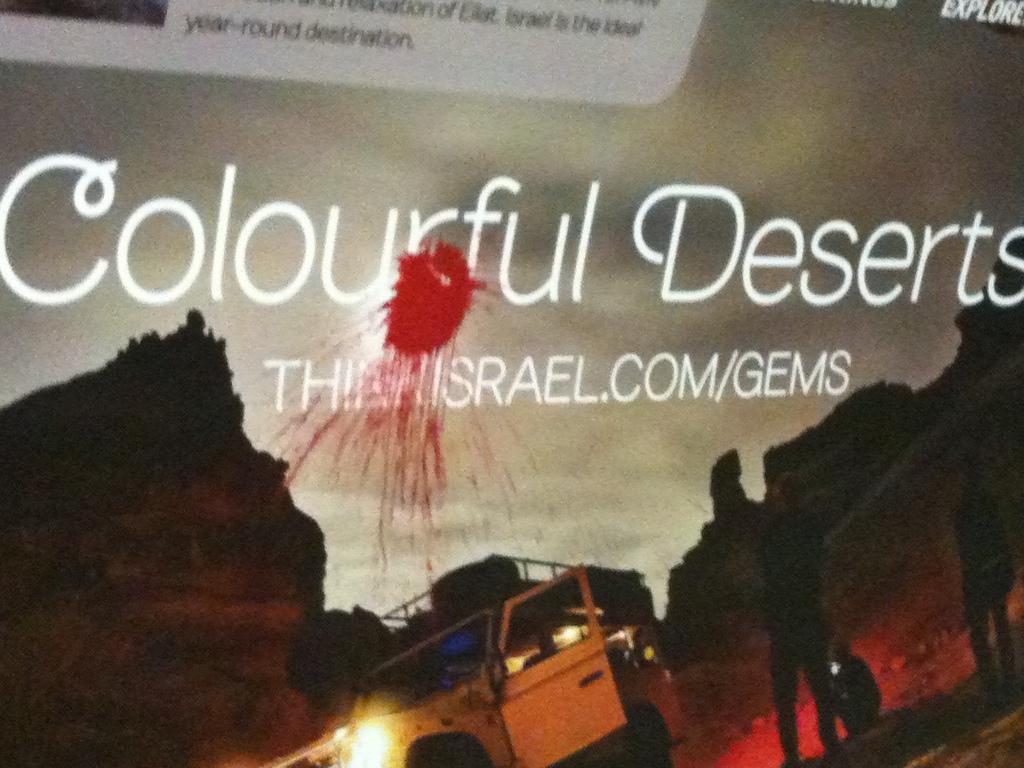What is the website for this ad?
Your answer should be very brief. Thinkisrael.com/gems. What kind of deserts?
Offer a very short reply. Colourful. 